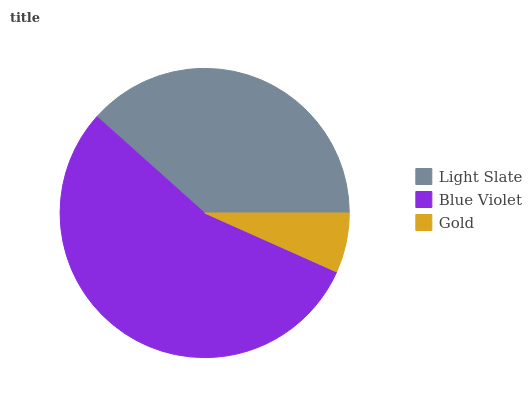Is Gold the minimum?
Answer yes or no. Yes. Is Blue Violet the maximum?
Answer yes or no. Yes. Is Blue Violet the minimum?
Answer yes or no. No. Is Gold the maximum?
Answer yes or no. No. Is Blue Violet greater than Gold?
Answer yes or no. Yes. Is Gold less than Blue Violet?
Answer yes or no. Yes. Is Gold greater than Blue Violet?
Answer yes or no. No. Is Blue Violet less than Gold?
Answer yes or no. No. Is Light Slate the high median?
Answer yes or no. Yes. Is Light Slate the low median?
Answer yes or no. Yes. Is Blue Violet the high median?
Answer yes or no. No. Is Gold the low median?
Answer yes or no. No. 